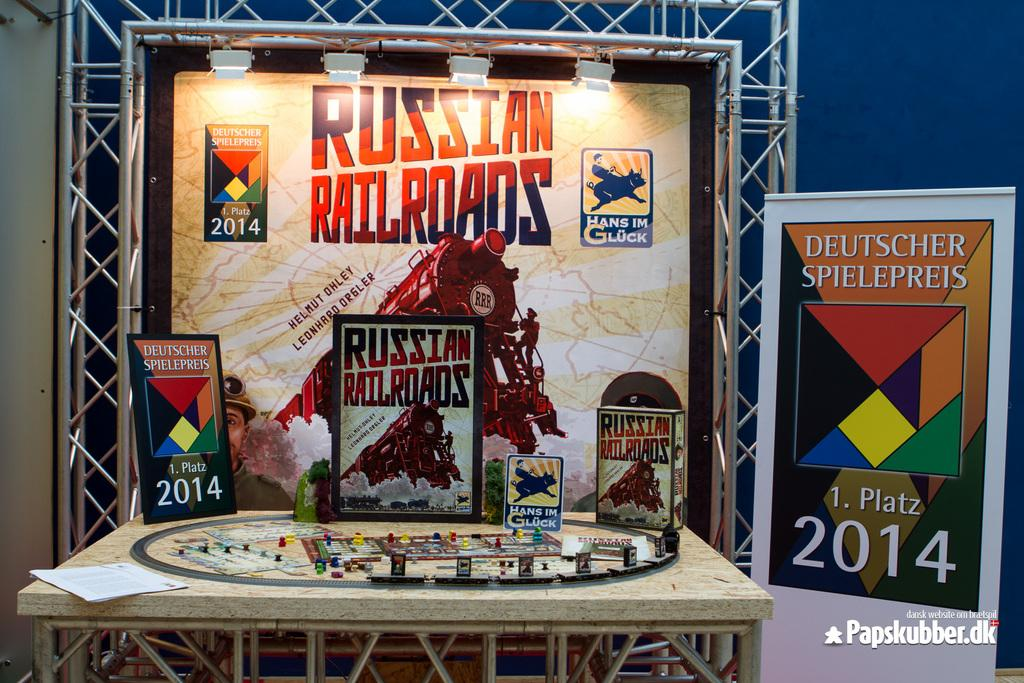<image>
Share a concise interpretation of the image provided. A Russian Railroad display has the year 2014 displayed. 